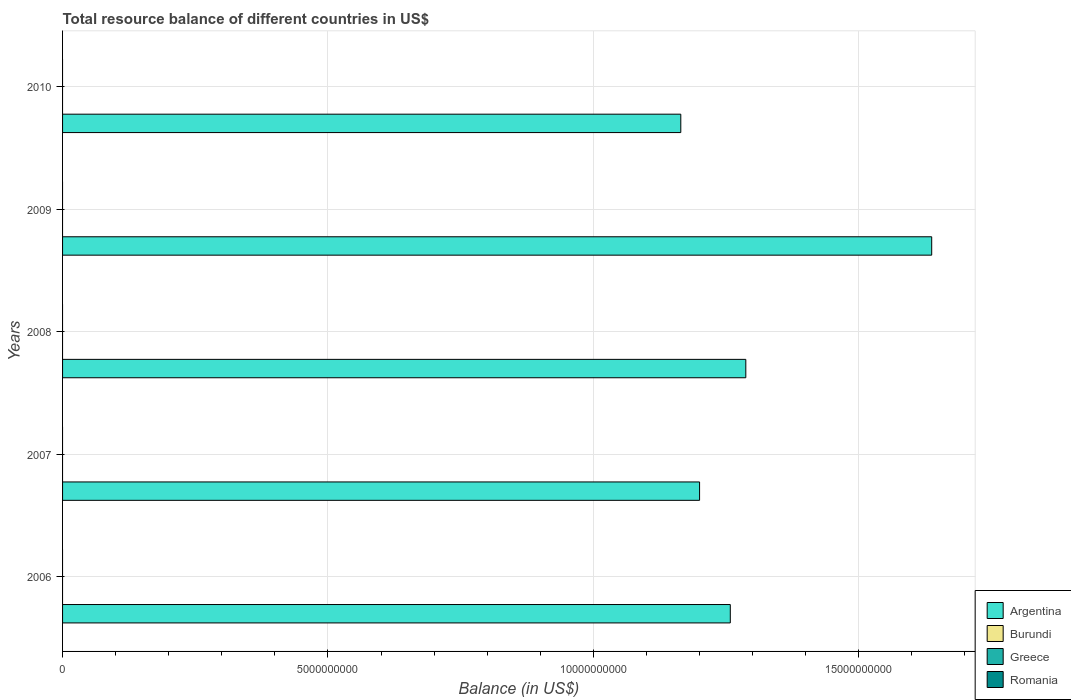Are the number of bars on each tick of the Y-axis equal?
Give a very brief answer. Yes. How many bars are there on the 1st tick from the bottom?
Make the answer very short. 1. What is the label of the 4th group of bars from the top?
Your response must be concise. 2007. In how many cases, is the number of bars for a given year not equal to the number of legend labels?
Make the answer very short. 5. What is the total resource balance in Greece in 2008?
Offer a terse response. 0. Across all years, what is the maximum total resource balance in Argentina?
Provide a short and direct response. 1.64e+1. In which year was the total resource balance in Argentina maximum?
Your response must be concise. 2009. What is the total total resource balance in Burundi in the graph?
Give a very brief answer. 0. What is the difference between the total resource balance in Argentina in 2006 and that in 2010?
Offer a very short reply. 9.33e+08. What is the difference between the total resource balance in Romania in 2009 and the total resource balance in Argentina in 2007?
Your answer should be compact. -1.20e+1. What is the average total resource balance in Burundi per year?
Your answer should be compact. 0. In how many years, is the total resource balance in Burundi greater than 13000000000 US$?
Provide a short and direct response. 0. What is the difference between the highest and the second highest total resource balance in Argentina?
Ensure brevity in your answer.  3.50e+09. Is it the case that in every year, the sum of the total resource balance in Burundi and total resource balance in Romania is greater than the total resource balance in Greece?
Give a very brief answer. No. How many years are there in the graph?
Offer a very short reply. 5. How many legend labels are there?
Provide a succinct answer. 4. What is the title of the graph?
Ensure brevity in your answer.  Total resource balance of different countries in US$. What is the label or title of the X-axis?
Make the answer very short. Balance (in US$). What is the label or title of the Y-axis?
Make the answer very short. Years. What is the Balance (in US$) of Argentina in 2006?
Your answer should be very brief. 1.26e+1. What is the Balance (in US$) in Burundi in 2006?
Offer a terse response. 0. What is the Balance (in US$) in Romania in 2006?
Make the answer very short. 0. What is the Balance (in US$) of Argentina in 2007?
Your answer should be very brief. 1.20e+1. What is the Balance (in US$) of Greece in 2007?
Ensure brevity in your answer.  0. What is the Balance (in US$) in Argentina in 2008?
Offer a terse response. 1.29e+1. What is the Balance (in US$) of Greece in 2008?
Offer a terse response. 0. What is the Balance (in US$) of Romania in 2008?
Provide a short and direct response. 0. What is the Balance (in US$) of Argentina in 2009?
Provide a short and direct response. 1.64e+1. What is the Balance (in US$) of Burundi in 2009?
Make the answer very short. 0. What is the Balance (in US$) of Argentina in 2010?
Make the answer very short. 1.16e+1. What is the Balance (in US$) of Burundi in 2010?
Provide a succinct answer. 0. What is the Balance (in US$) of Greece in 2010?
Your answer should be compact. 0. What is the Balance (in US$) in Romania in 2010?
Your answer should be compact. 0. Across all years, what is the maximum Balance (in US$) of Argentina?
Your response must be concise. 1.64e+1. Across all years, what is the minimum Balance (in US$) of Argentina?
Make the answer very short. 1.16e+1. What is the total Balance (in US$) of Argentina in the graph?
Make the answer very short. 6.55e+1. What is the total Balance (in US$) in Greece in the graph?
Ensure brevity in your answer.  0. What is the difference between the Balance (in US$) in Argentina in 2006 and that in 2007?
Offer a very short reply. 5.79e+08. What is the difference between the Balance (in US$) in Argentina in 2006 and that in 2008?
Make the answer very short. -2.92e+08. What is the difference between the Balance (in US$) in Argentina in 2006 and that in 2009?
Offer a terse response. -3.79e+09. What is the difference between the Balance (in US$) in Argentina in 2006 and that in 2010?
Your response must be concise. 9.33e+08. What is the difference between the Balance (in US$) in Argentina in 2007 and that in 2008?
Provide a succinct answer. -8.71e+08. What is the difference between the Balance (in US$) in Argentina in 2007 and that in 2009?
Your answer should be compact. -4.37e+09. What is the difference between the Balance (in US$) in Argentina in 2007 and that in 2010?
Offer a terse response. 3.54e+08. What is the difference between the Balance (in US$) in Argentina in 2008 and that in 2009?
Offer a very short reply. -3.50e+09. What is the difference between the Balance (in US$) in Argentina in 2008 and that in 2010?
Keep it short and to the point. 1.22e+09. What is the difference between the Balance (in US$) of Argentina in 2009 and that in 2010?
Your response must be concise. 4.73e+09. What is the average Balance (in US$) of Argentina per year?
Offer a very short reply. 1.31e+1. What is the average Balance (in US$) of Burundi per year?
Ensure brevity in your answer.  0. What is the average Balance (in US$) in Romania per year?
Offer a very short reply. 0. What is the ratio of the Balance (in US$) of Argentina in 2006 to that in 2007?
Make the answer very short. 1.05. What is the ratio of the Balance (in US$) in Argentina in 2006 to that in 2008?
Your answer should be very brief. 0.98. What is the ratio of the Balance (in US$) in Argentina in 2006 to that in 2009?
Make the answer very short. 0.77. What is the ratio of the Balance (in US$) in Argentina in 2006 to that in 2010?
Ensure brevity in your answer.  1.08. What is the ratio of the Balance (in US$) in Argentina in 2007 to that in 2008?
Make the answer very short. 0.93. What is the ratio of the Balance (in US$) in Argentina in 2007 to that in 2009?
Provide a succinct answer. 0.73. What is the ratio of the Balance (in US$) of Argentina in 2007 to that in 2010?
Your answer should be very brief. 1.03. What is the ratio of the Balance (in US$) in Argentina in 2008 to that in 2009?
Keep it short and to the point. 0.79. What is the ratio of the Balance (in US$) of Argentina in 2008 to that in 2010?
Your response must be concise. 1.11. What is the ratio of the Balance (in US$) in Argentina in 2009 to that in 2010?
Provide a short and direct response. 1.41. What is the difference between the highest and the second highest Balance (in US$) in Argentina?
Ensure brevity in your answer.  3.50e+09. What is the difference between the highest and the lowest Balance (in US$) in Argentina?
Provide a short and direct response. 4.73e+09. 